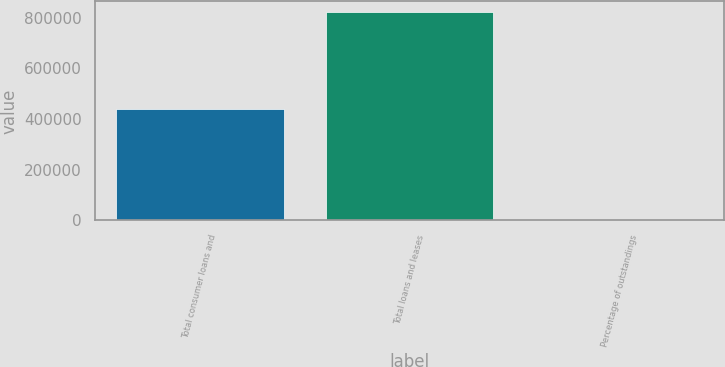Convert chart to OTSL. <chart><loc_0><loc_0><loc_500><loc_500><bar_chart><fcel>Total consumer loans and<fcel>Total loans and leases<fcel>Percentage of outstandings<nl><fcel>438974<fcel>823520<fcel>93.44<nl></chart> 